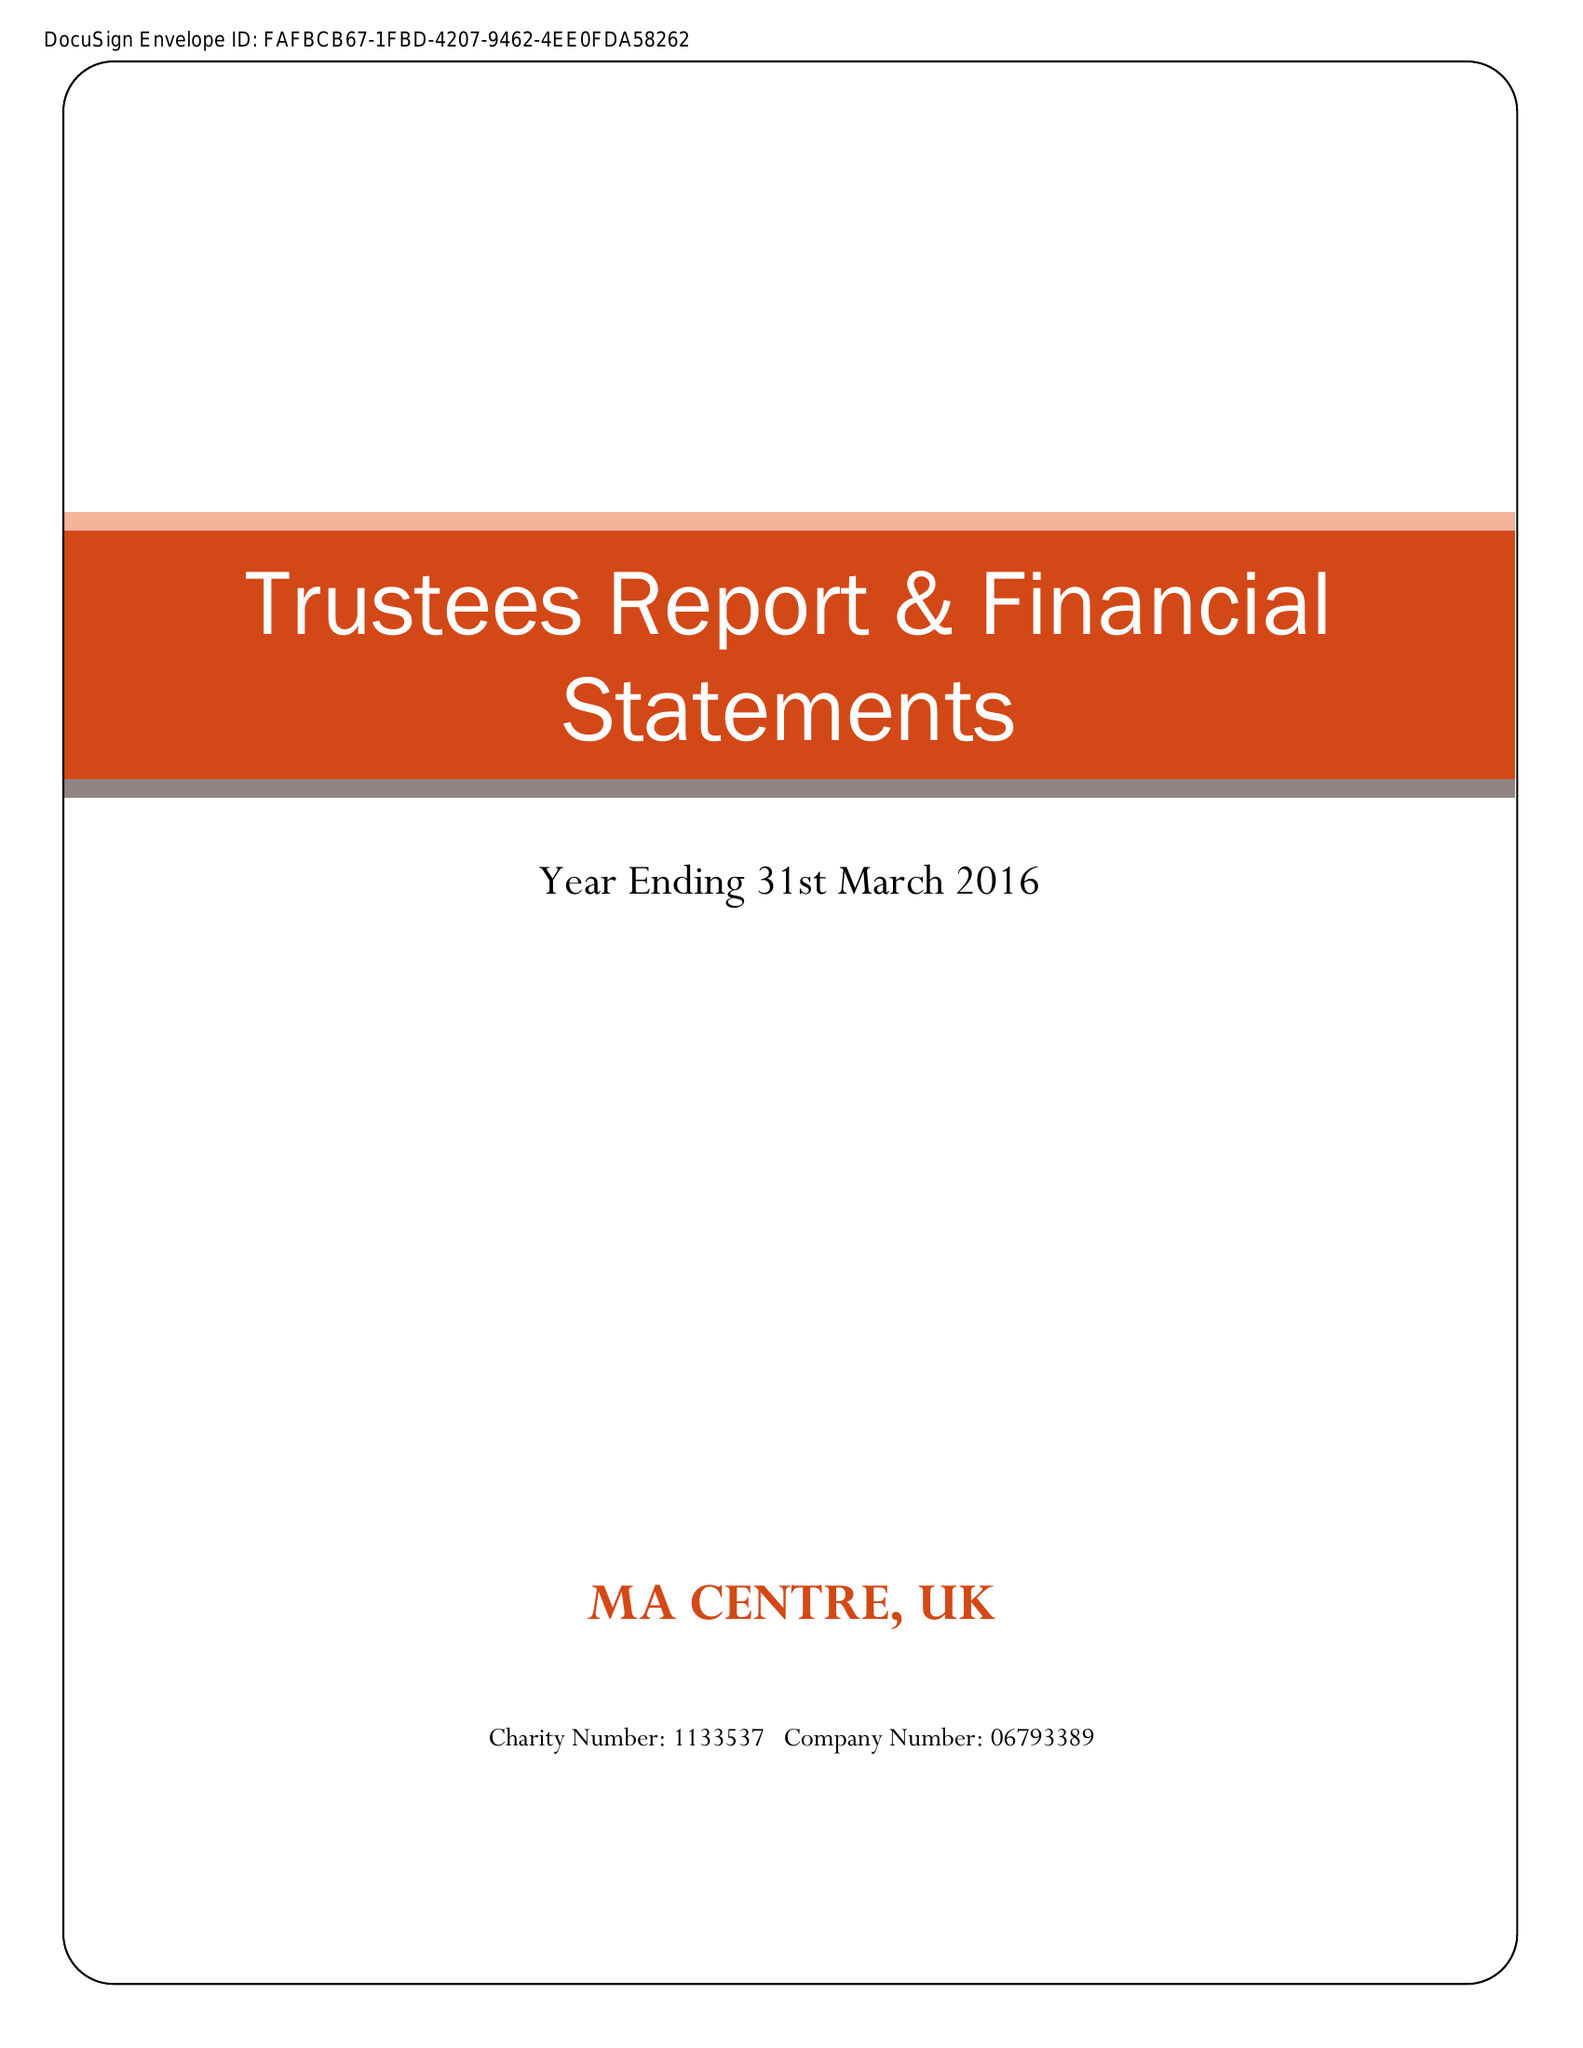What is the value for the spending_annually_in_british_pounds?
Answer the question using a single word or phrase. 415.00 